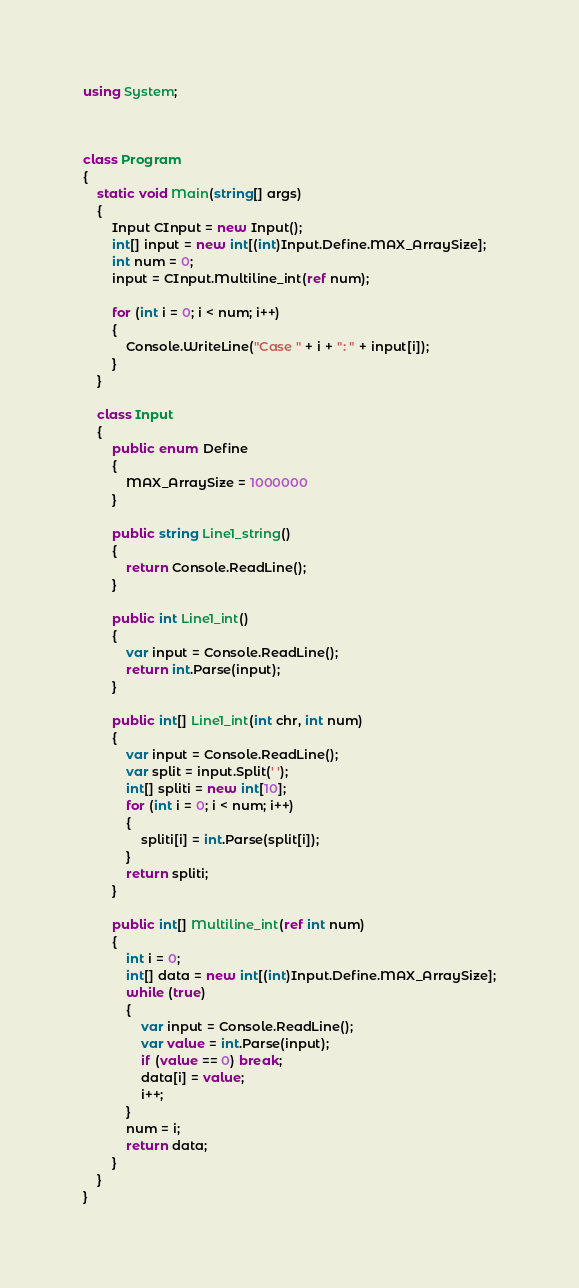<code> <loc_0><loc_0><loc_500><loc_500><_C#_>using System;



class Program
{
    static void Main(string[] args)
    {
        Input CInput = new Input();
        int[] input = new int[(int)Input.Define.MAX_ArraySize];
        int num = 0;
        input = CInput.Multiline_int(ref num);

        for (int i = 0; i < num; i++)
        {
            Console.WriteLine("Case " + i + ": " + input[i]);
        }
    }

    class Input
    {
        public enum Define
        {
            MAX_ArraySize = 1000000
        }

        public string Line1_string()
        {
            return Console.ReadLine();
        }

        public int Line1_int()
        {
            var input = Console.ReadLine();
            return int.Parse(input);
        }

        public int[] Line1_int(int chr, int num)
        {
            var input = Console.ReadLine();
            var split = input.Split(' ');
            int[] spliti = new int[10];
            for (int i = 0; i < num; i++)
            {
                spliti[i] = int.Parse(split[i]);
            }
            return spliti;
        }

        public int[] Multiline_int(ref int num)
        {
            int i = 0;
            int[] data = new int[(int)Input.Define.MAX_ArraySize];
            while (true)
            {
                var input = Console.ReadLine();
                var value = int.Parse(input);
                if (value == 0) break;
                data[i] = value;
                i++;
            }
            num = i;
            return data;
        }
    }
}</code> 